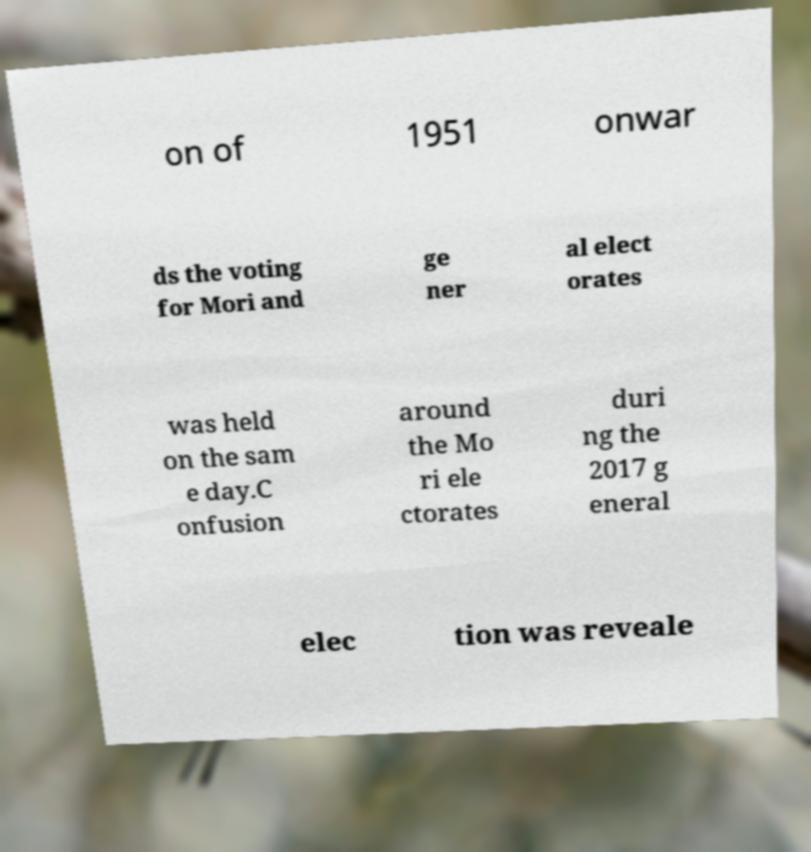Could you extract and type out the text from this image? on of 1951 onwar ds the voting for Mori and ge ner al elect orates was held on the sam e day.C onfusion around the Mo ri ele ctorates duri ng the 2017 g eneral elec tion was reveale 